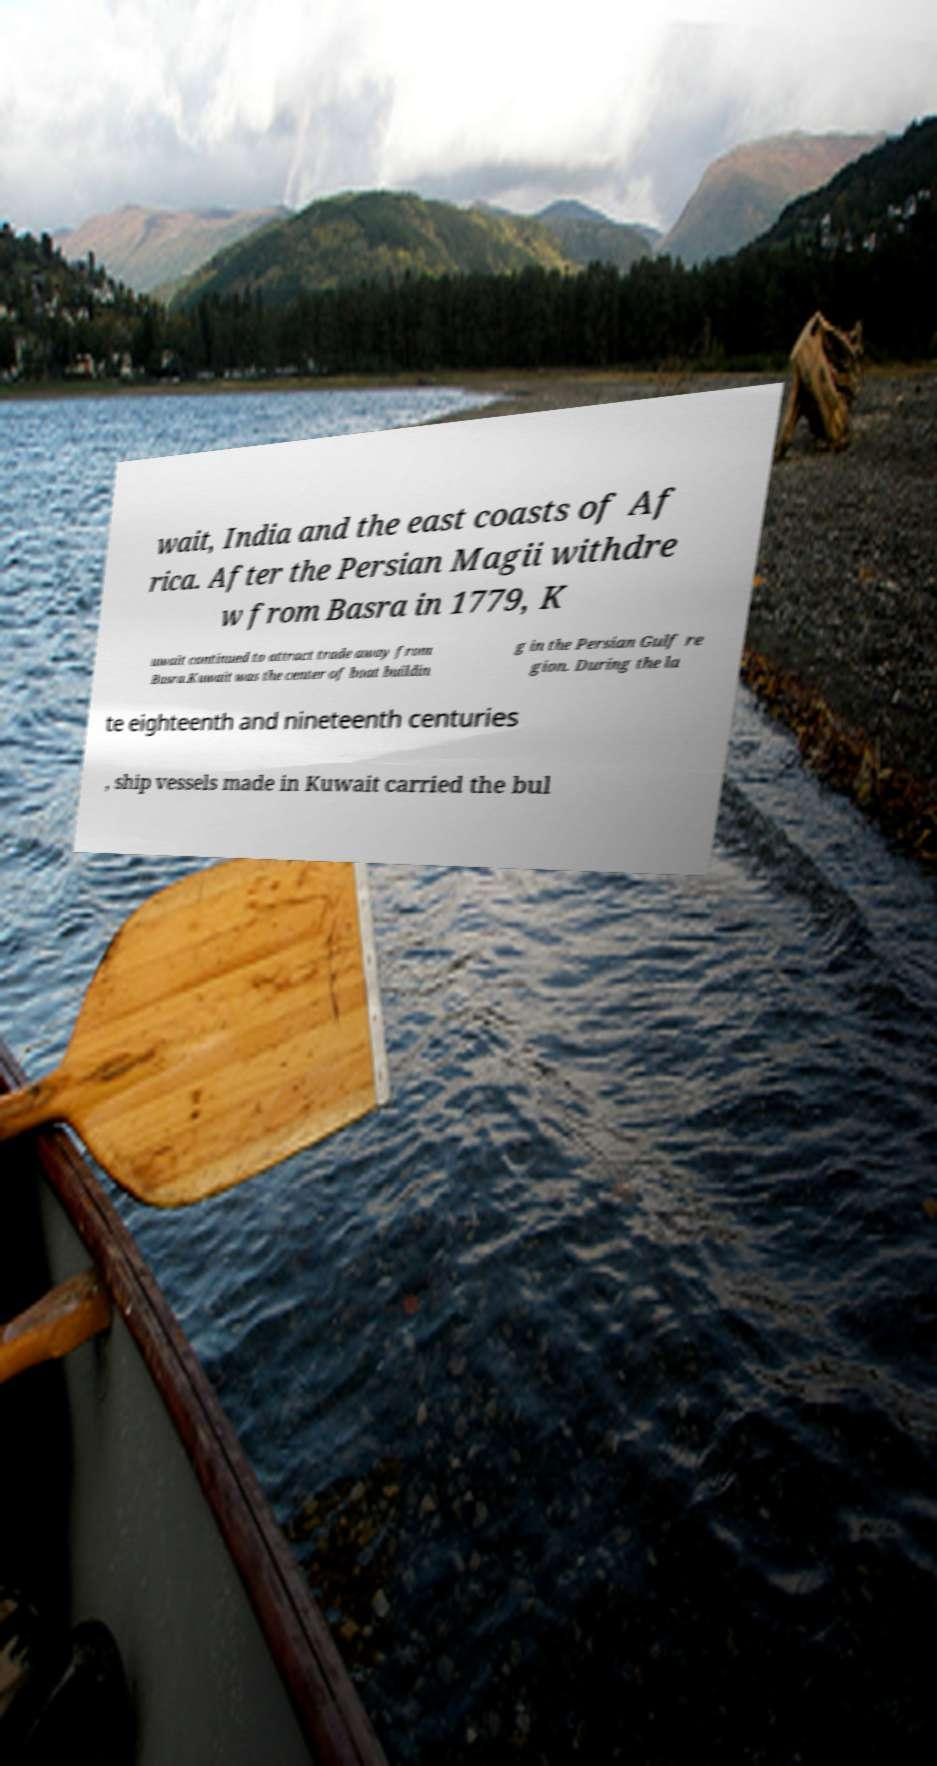Please read and relay the text visible in this image. What does it say? wait, India and the east coasts of Af rica. After the Persian Magii withdre w from Basra in 1779, K uwait continued to attract trade away from Basra.Kuwait was the center of boat buildin g in the Persian Gulf re gion. During the la te eighteenth and nineteenth centuries , ship vessels made in Kuwait carried the bul 